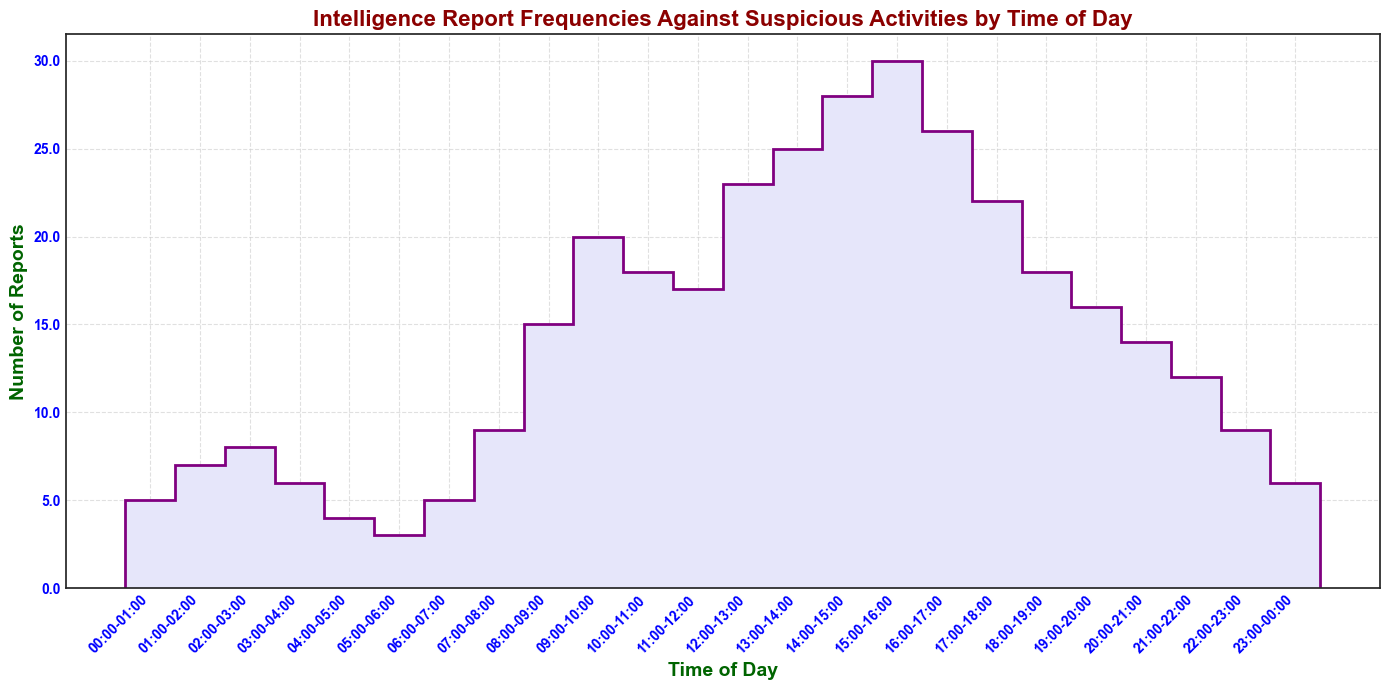What's the time interval with the highest number of intelligence reports? Look for the time interval on the x-axis that has the tallest step in the stairs plot indicating the highest value on the y-axis. The time interval 15:00-16:00 has 30 reports, which is the highest.
Answer: 15:00-16:00 During which time intervals are the intelligence reports greater than 20? Identify and list all time intervals where the steps are above the y-axis value of 20. These intervals are 12:00-13:00 (23), 13:00-14:00 (25), 14:00-15:00 (28), and 15:00-16:00 (30).
Answer: 12:00-13:00, 13:00-14:00, 14:00-15:00, 15:00-16:00 What is the total number of intelligence reports from 00:00 to 05:00? Sum the values of the reports from the intervals 00:00-01:00 (5), 01:00-02:00 (7), 02:00-03:00 (8), 03:00-04:00 (6), and 04:00-05:00 (4). The total is 5 + 7 + 8 + 6 + 4 = 30.
Answer: 30 Compare the number of reports between the intervals 08:00-09:00 and 09:00-10:00 and determine the one with more reports. Look at the heights of the steps corresponding to 08:00-09:00 (15) and 09:00-10:00 (20). The interval 09:00-10:00 has more reports (20 > 15).
Answer: 09:00-10:00 What is the average number of reports between 10:00 and 12:00? Identify the number of reports in the intervals 10:00-11:00 (18) and 11:00-12:00 (17), then calculate their average: (18 + 17) / 2 = 17.5.
Answer: 17.5 How many more reports were there during 15:00-16:00 compared to 20:00-21:00? Determine the number of reports in 15:00-16:00 (30) and 20:00-21:00 (14). Calculate the difference: 30 - 14 = 16.
Answer: 16 During which hour do we first see a significant increase in the number of reports? Inspect the plot to identify the first interval where the step height increases notably. The first significant increase occurs at 08:00-09:00 with 15 reports, following a steady rise from 06:00-07:00 (5) and 07:00-08:00 (9).
Answer: 08:00-09:00 What is the trend in intelligence reports from 18:00 to 00:00? Observe the steps from 18:00-18:00 to 23:00-00:00. There is a notable declining trend: 18 (18:00-19:00), 16 (19:00-20:00), 14 (20:00-21:00), 12 (21:00-22:00), 9 (22:00-23:00), and 6 (23:00-00:00).
Answer: Declining What is the median number of reports between 00:00 and 12:00? List out the report numbers from 00:00-01:00 to 11:00-12:00: 5, 7, 8, 6, 4, 3, 5, 9, 15, 20, 18, 17. Arrange them in ascending order: 3, 4, 5, 5, 6, 7, 8, 9, 15, 17, 18, 20. The median is the average of the 6th and 7th values: (7 + 8) / 2 = 7.5.
Answer: 7.5 What visual elements enhance the readability of this plot? Analyze the visual elements such as color, labels, grid, and font. Colors like lavender and purple highlight the steps, dark green labels for axes, dark red for the title, bold fonts for clarity, and gridlines help in reading values accurately.
Answer: Colors, labels, grid, bold fonts 